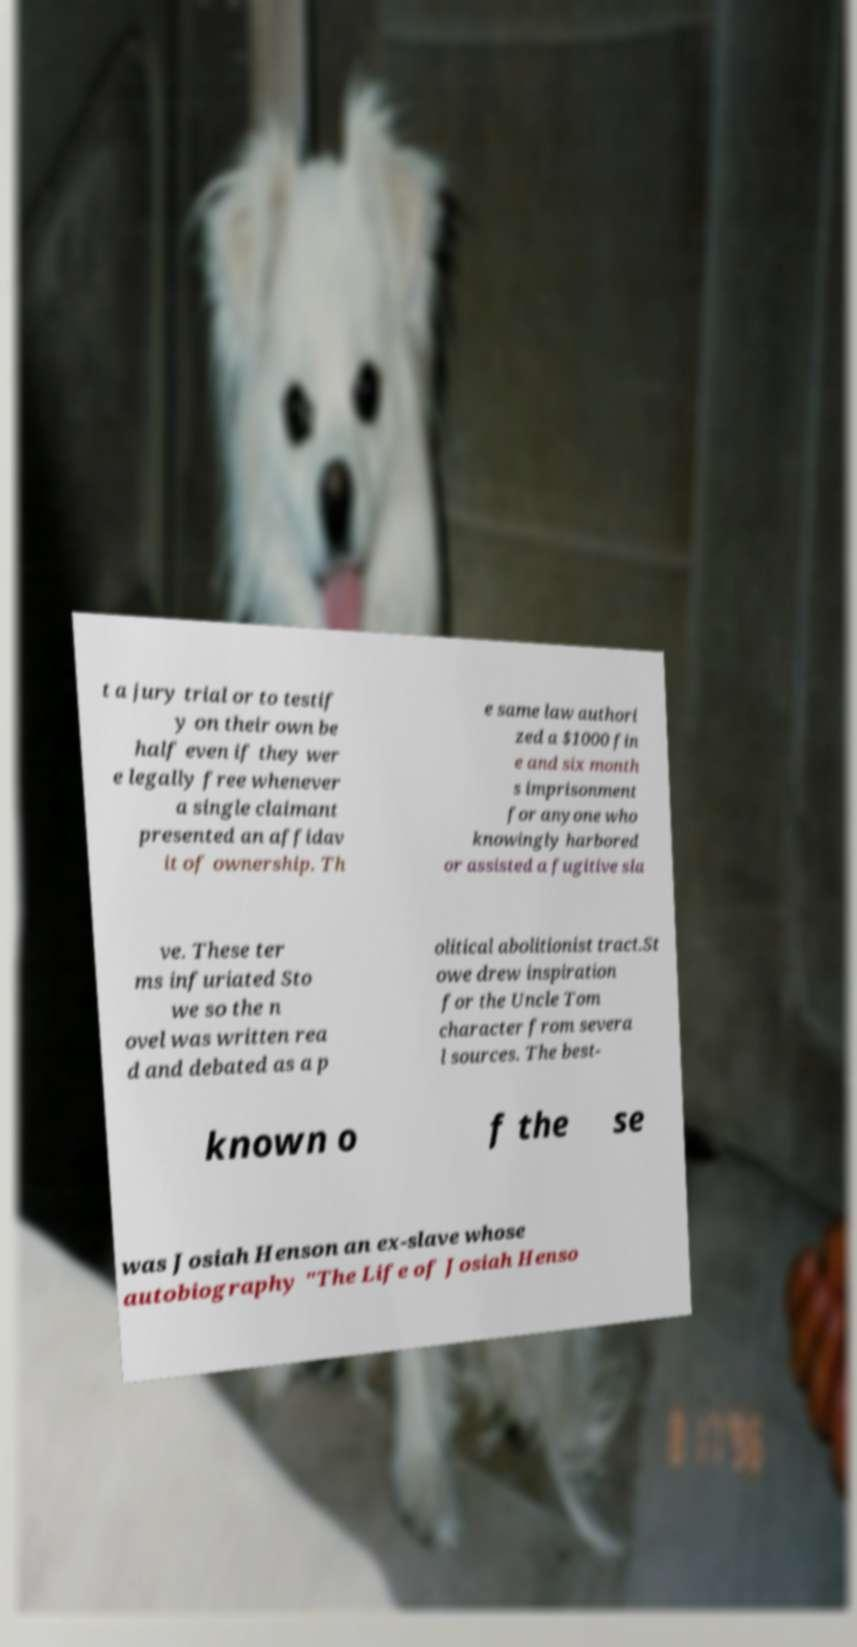What messages or text are displayed in this image? I need them in a readable, typed format. t a jury trial or to testif y on their own be half even if they wer e legally free whenever a single claimant presented an affidav it of ownership. Th e same law authori zed a $1000 fin e and six month s imprisonment for anyone who knowingly harbored or assisted a fugitive sla ve. These ter ms infuriated Sto we so the n ovel was written rea d and debated as a p olitical abolitionist tract.St owe drew inspiration for the Uncle Tom character from severa l sources. The best- known o f the se was Josiah Henson an ex-slave whose autobiography "The Life of Josiah Henso 